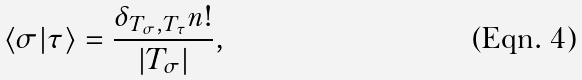<formula> <loc_0><loc_0><loc_500><loc_500>\langle \sigma | \tau \rangle = \frac { \delta _ { T _ { \sigma } , T _ { \tau } } n ! } { | T _ { \sigma } | } ,</formula> 